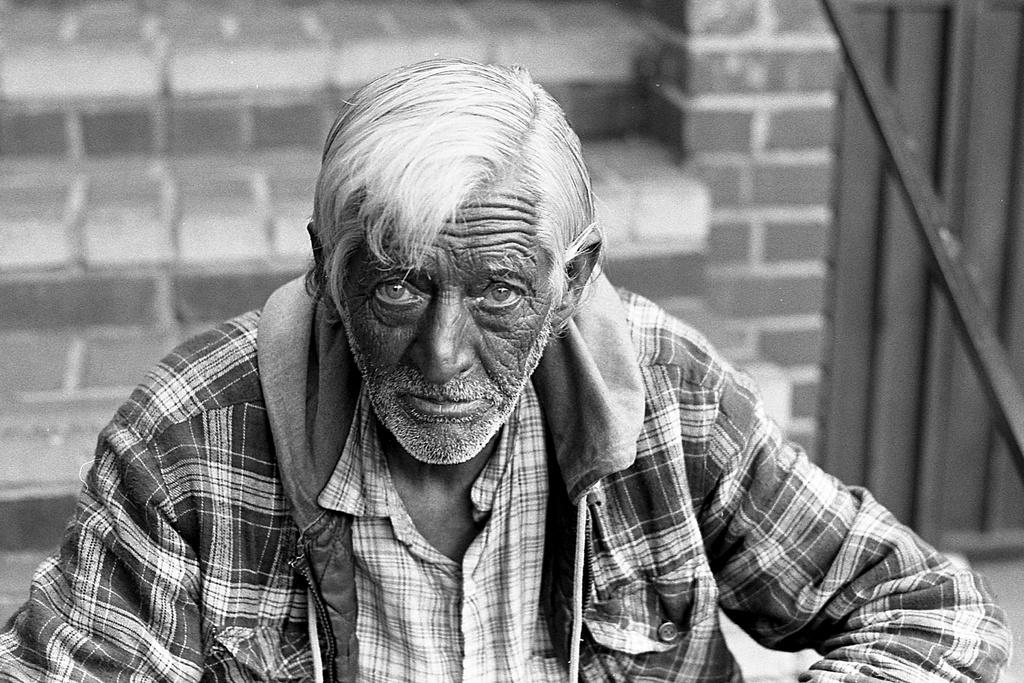What is the color scheme of the image? The image is black and white. Can you describe the person in the image? The person in the image is wearing a shirt and a jerkin. What type of door can be seen in the image? There is a wooden door in the image. Are there any architectural features visible in the image? Yes, there are stairs in the image. What type of sugar is being used to sweeten the person's neck in the image? There is no sugar or reference to sweetening in the image; the person is wearing a shirt and a jerkin. 